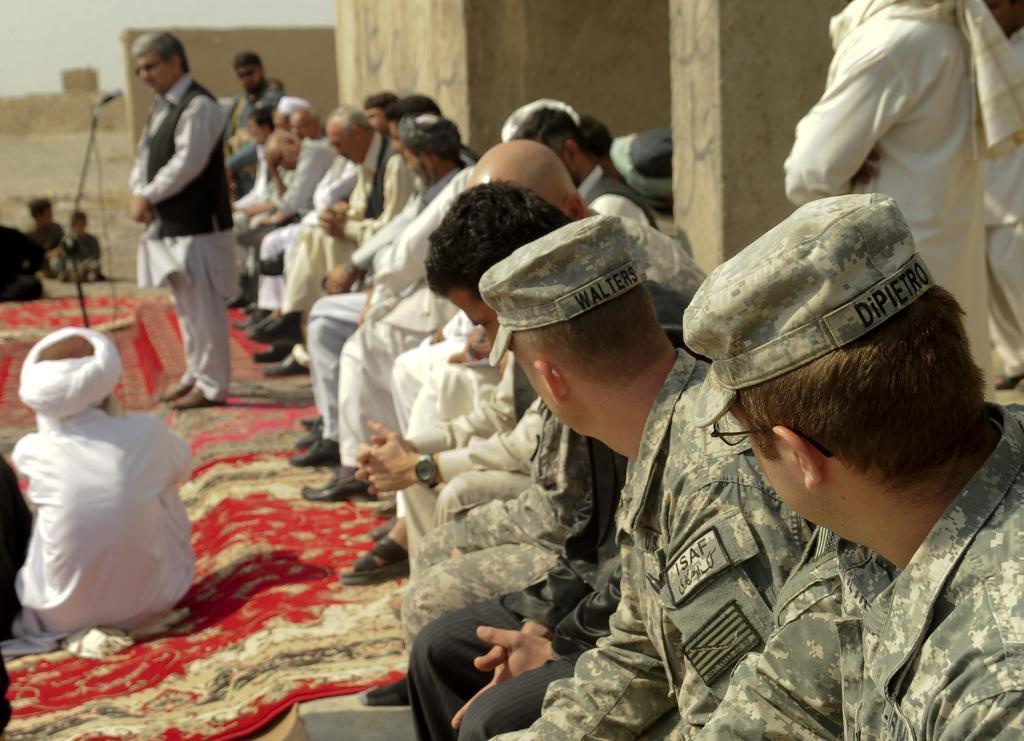How would you summarize this image in a sentence or two? In this picture we can see some people are sitting and some are standing, among them one person is standing and talking in front of mike. 